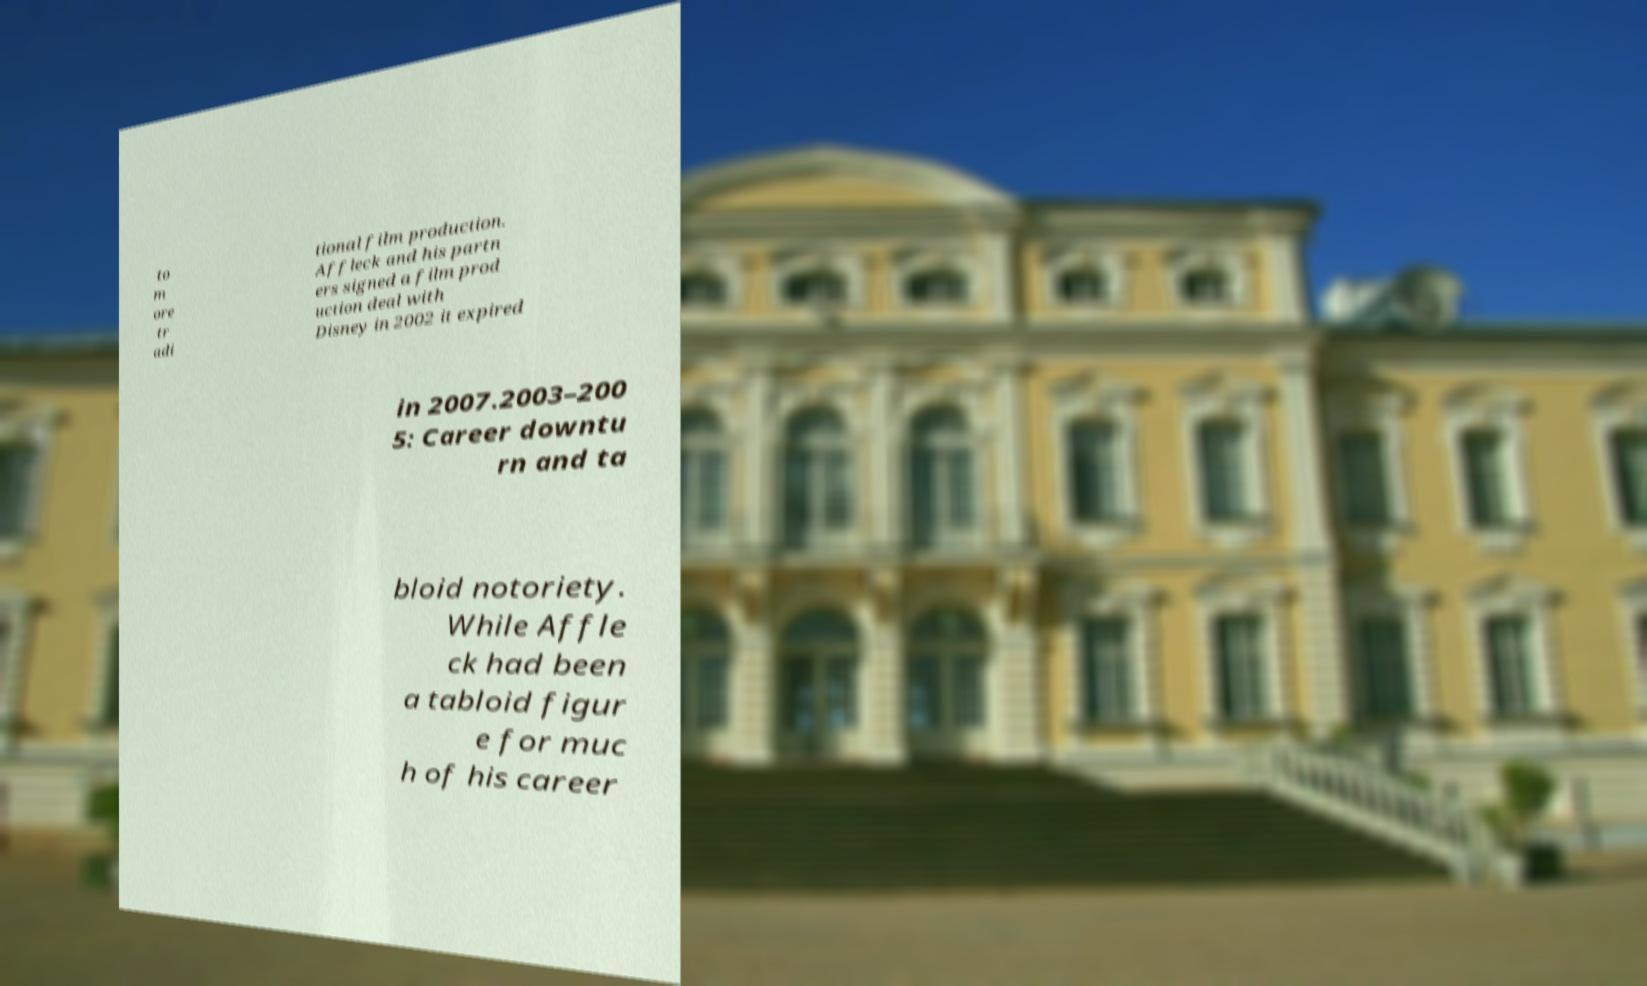For documentation purposes, I need the text within this image transcribed. Could you provide that? to m ore tr adi tional film production. Affleck and his partn ers signed a film prod uction deal with Disney in 2002 it expired in 2007.2003–200 5: Career downtu rn and ta bloid notoriety. While Affle ck had been a tabloid figur e for muc h of his career 